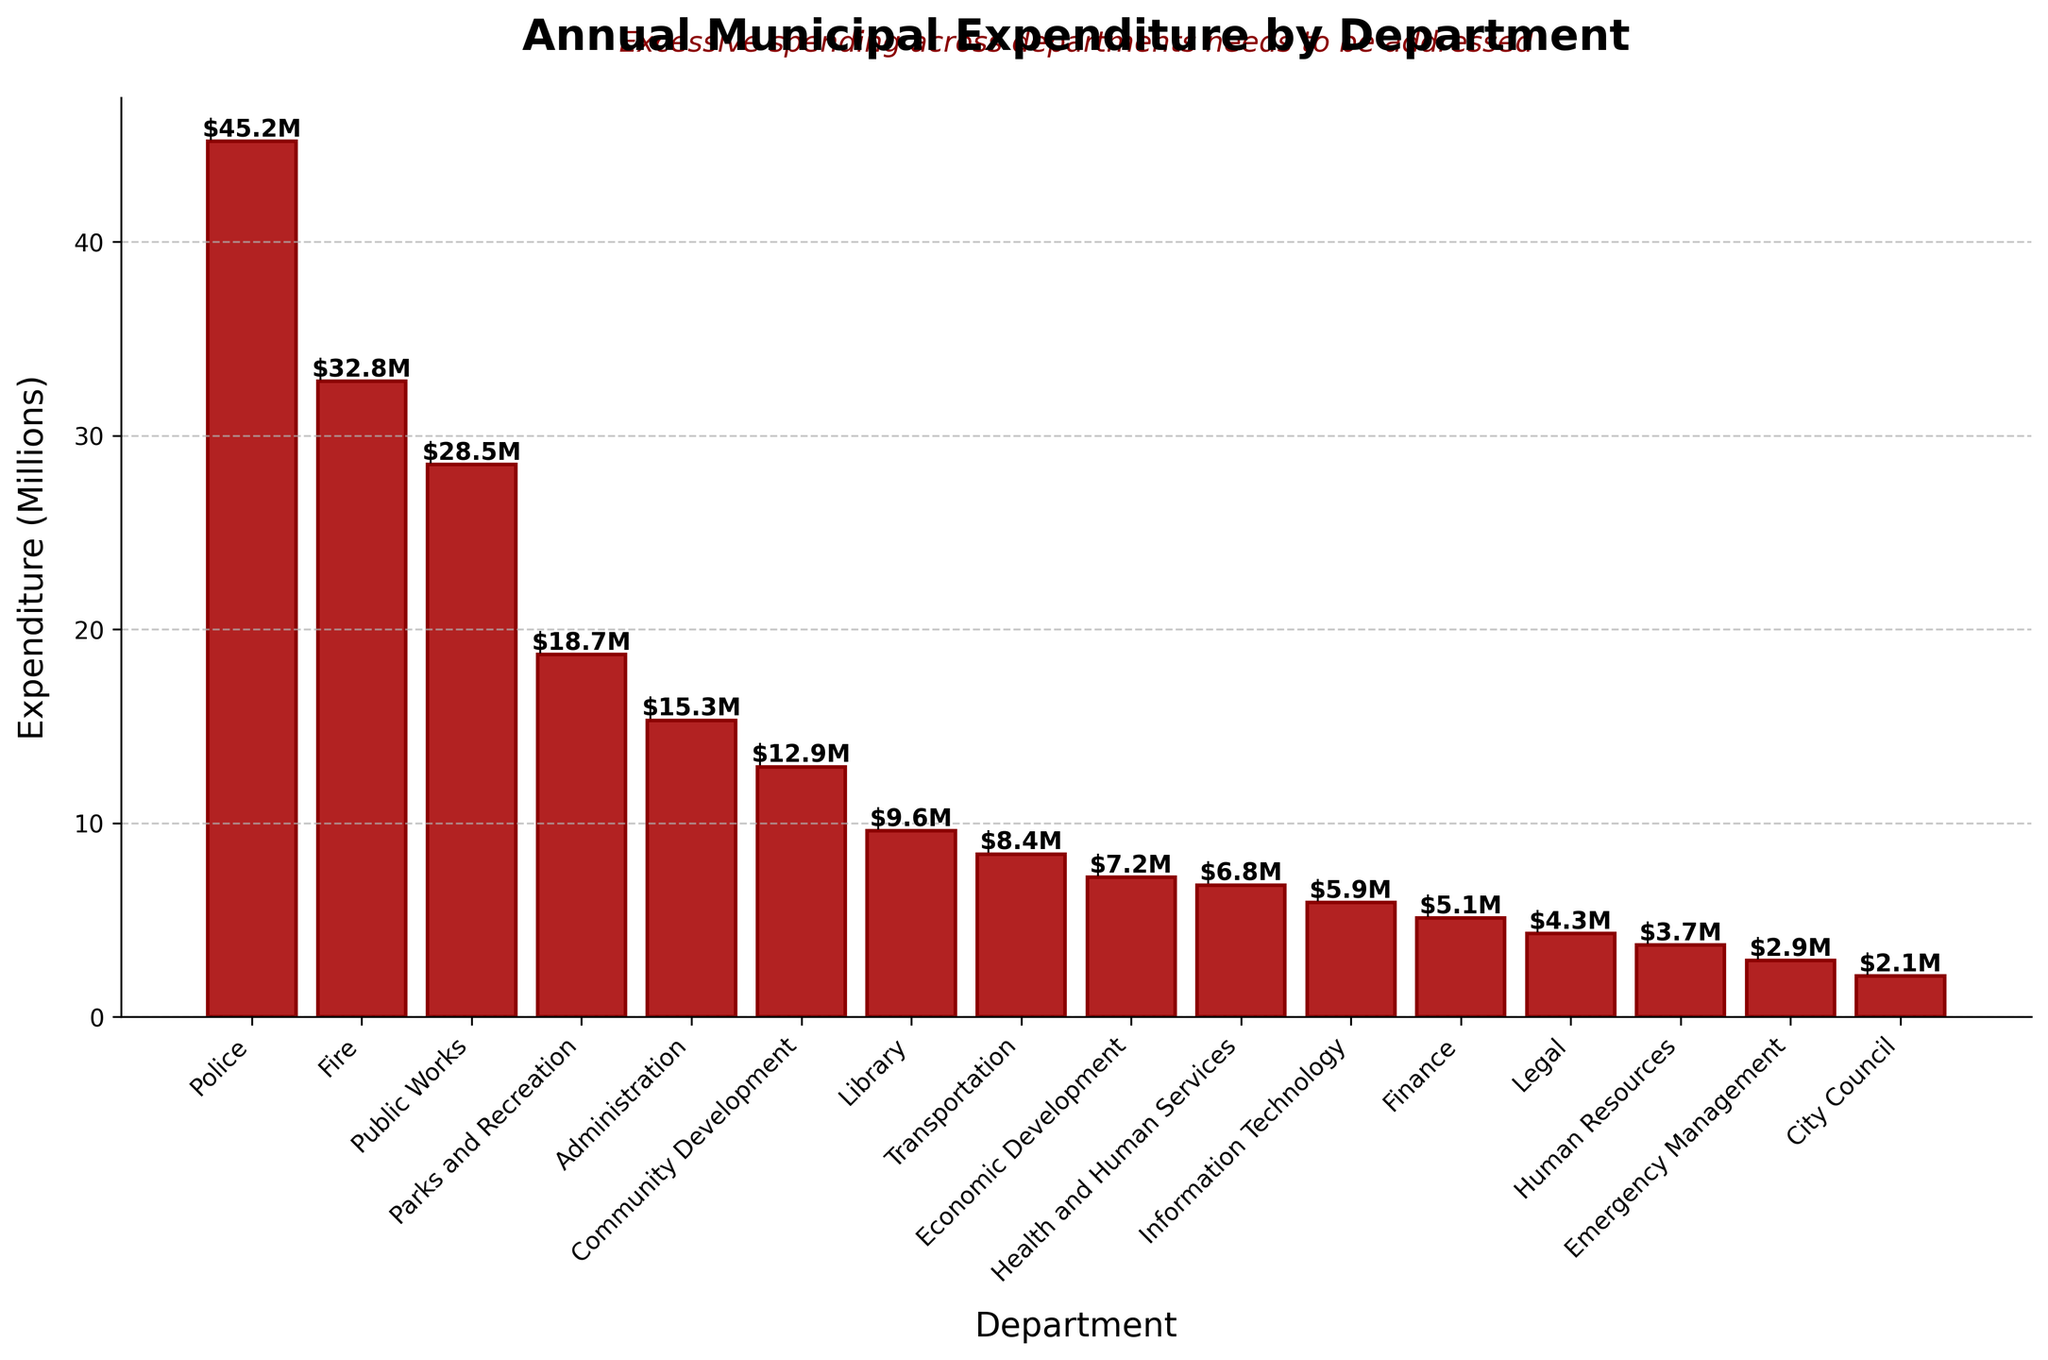What's the average expenditure of the top 5 departments? To find the average, first sum the expenditure of the top 5 departments: Police ($45.2M), Fire ($32.8M), Public Works ($28.5M), Parks and Recreation ($18.7M), Administration ($15.3M). The sum is 45.2 + 32.8 + 28.5 + 18.7 + 15.3 = $140.5M. Then divide by 5 to find the average: 140.5 / 5 = $28.1M
Answer: $28.1M How much more is spent on Police and Fire combined compared to Administration and Library combined? First, find the combined expenditure for Police and Fire: $45.2M + $32.8M = $78M. Then find the combined expenditure for Administration and Library: $15.3M + $9.6M = $24.9M. Subtract the two sums: 78 - 24.9 = $53.1M
Answer: $53.1M Which department has the lowest expenditure and how much is it? By inspecting the heights of the bars and labels, the City Council department has the lowest expenditure at $2.1M
Answer: City Council, $2.1M Are there more departments with an expenditure above or below $10M? Count the number of bars above $10M: Police, Fire, Public Works, Parks and Recreation, Administration, Community Development (6). Count the number of bars below $10M: Library, Transportation, Economic Development, Health and Human Services, Information Technology, Finance, Legal, Human Resources, Emergency Management, City Council (10). There are more departments below $10M.
Answer: Below $10M How does the expenditure on Parks and Recreation compare to Public Works? Compare the heights/amounts from the bar chart. Parks and Recreation spends $18.7M, while Public Works spends $28.5M. Public Works spends $9.8M more.
Answer: Public Works spends $9.8M more What is the combined expenditure of all departments listed? Sum all the expenditures: $45.2M + $32.8M + $28.5M + $18.7M + $15.3M + $12.9M + $9.6M + $8.4M + $7.2M + $6.8M + $5.9M + $5.1M + $4.3M + $3.7M + $2.9M + $2.1M = $209.4M
Answer: $209.4M Which two adjacent departments in the expenditure list have the closest expenditure values? Compare adjacent values in the sorted list for their differences: 
(1) Administration ($15.3M) and Community Development ($12.9M) difference is $2.4M,
(2) Community Development ($12.9M) and Library ($9.6M) difference is $3.3M,
(3) Library ($9.6M) and Transportation ($8.4M) difference is $1.2M.
Thus, Library and Transportation have the closest values with a difference of $1.2M
Answer: Library and Transportation, $1.2M How does the expenditure on Community Development compare to Economic Development? Community Development spends $12.9M, while Economic Development spends $7.2M. Subtracting those amounts: 12.9 - 7.2 = $5.7M difference
Answer: Community Development spends $5.7M more What is the median expenditure value among the departments? Order the expenditure values and find the middle value. There are 16 departments, so the median is the average of the 8th and 9th values in the sorted list:
Departments: 2.1, 2.9, 3.7, 4.3, 5.1, 5.9, 6.8, 7.2, 8.4, 9.6, 12.9, 15.3, 18.7, 28.5, 32.8, 45.2. 
Median is the average of 8.4 and 9.6: (8.4 + 9.6) / 2 = 9
Answer: $9M 